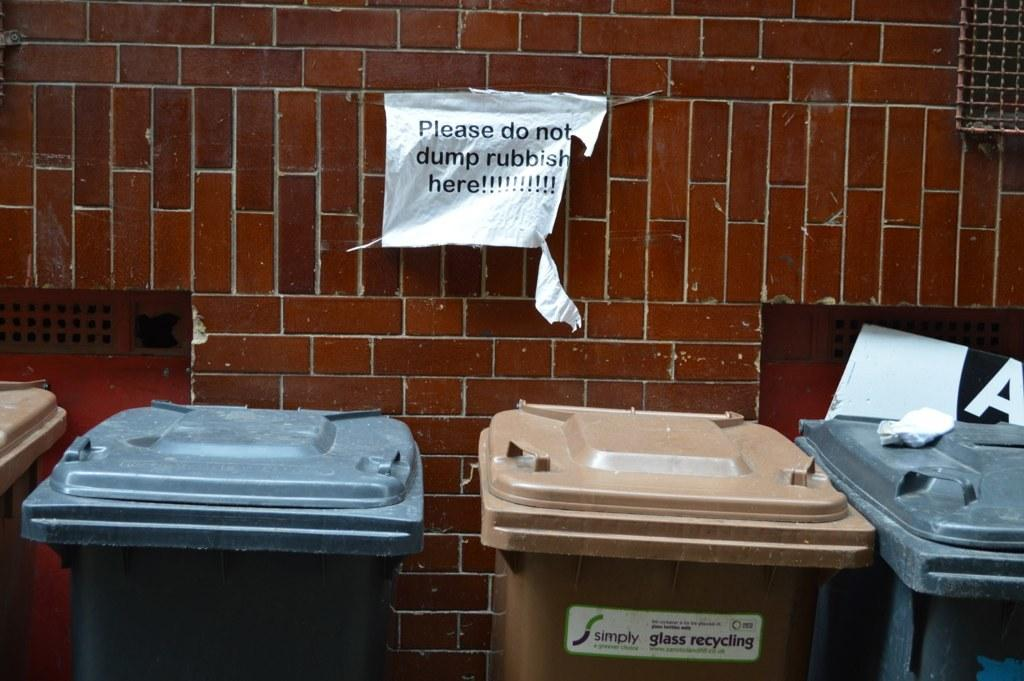<image>
Share a concise interpretation of the image provided. A sign behind garbage cans says "Please do not dump rubbish here". 